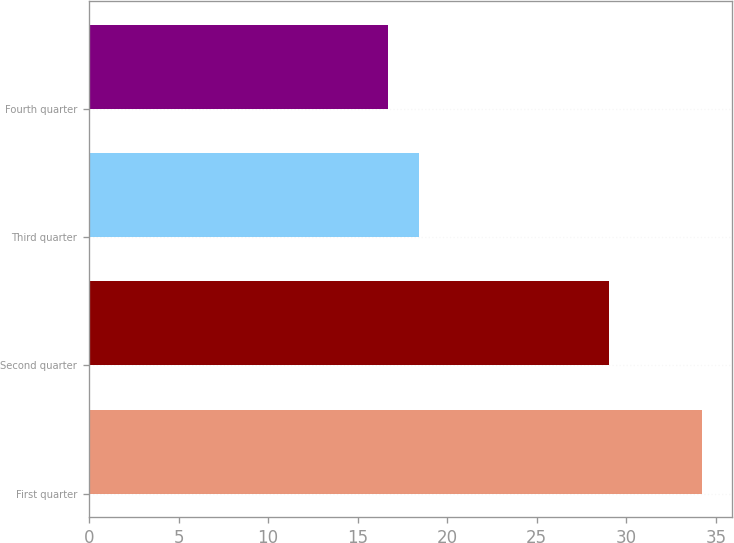<chart> <loc_0><loc_0><loc_500><loc_500><bar_chart><fcel>First quarter<fcel>Second quarter<fcel>Third quarter<fcel>Fourth quarter<nl><fcel>34.2<fcel>29.03<fcel>18.42<fcel>16.67<nl></chart> 